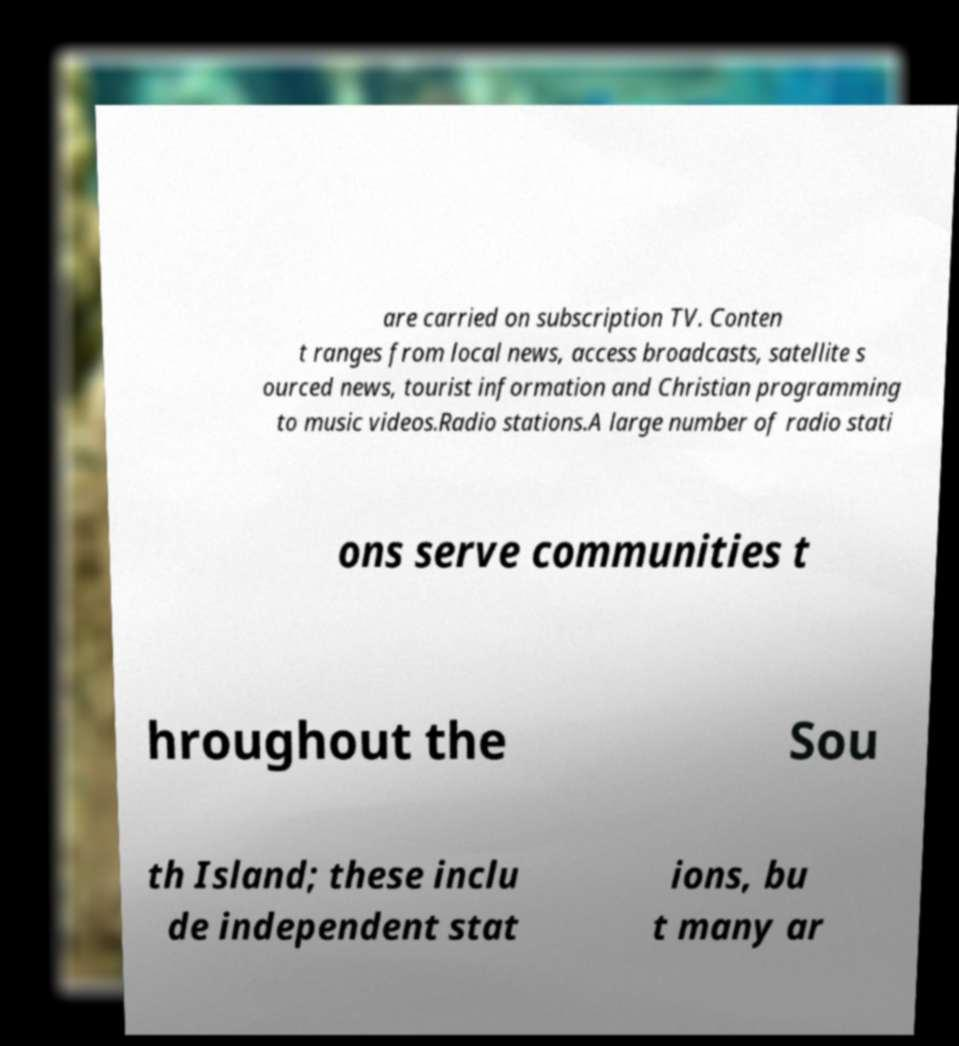Please identify and transcribe the text found in this image. are carried on subscription TV. Conten t ranges from local news, access broadcasts, satellite s ourced news, tourist information and Christian programming to music videos.Radio stations.A large number of radio stati ons serve communities t hroughout the Sou th Island; these inclu de independent stat ions, bu t many ar 